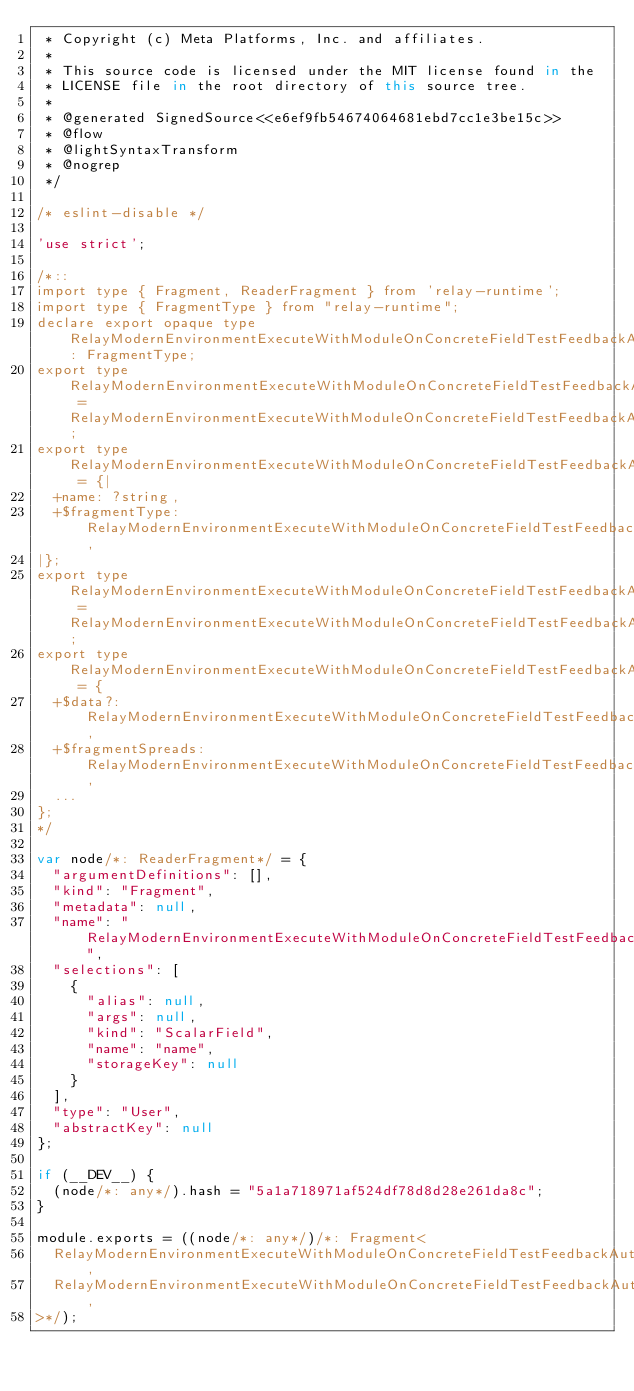Convert code to text. <code><loc_0><loc_0><loc_500><loc_500><_JavaScript_> * Copyright (c) Meta Platforms, Inc. and affiliates.
 * 
 * This source code is licensed under the MIT license found in the
 * LICENSE file in the root directory of this source tree.
 *
 * @generated SignedSource<<e6ef9fb54674064681ebd7cc1e3be15c>>
 * @flow
 * @lightSyntaxTransform
 * @nogrep
 */

/* eslint-disable */

'use strict';

/*::
import type { Fragment, ReaderFragment } from 'relay-runtime';
import type { FragmentType } from "relay-runtime";
declare export opaque type RelayModernEnvironmentExecuteWithModuleOnConcreteFieldTestFeedbackAuthor_author$fragmentType: FragmentType;
export type RelayModernEnvironmentExecuteWithModuleOnConcreteFieldTestFeedbackAuthor_author$ref = RelayModernEnvironmentExecuteWithModuleOnConcreteFieldTestFeedbackAuthor_author$fragmentType;
export type RelayModernEnvironmentExecuteWithModuleOnConcreteFieldTestFeedbackAuthor_author$data = {|
  +name: ?string,
  +$fragmentType: RelayModernEnvironmentExecuteWithModuleOnConcreteFieldTestFeedbackAuthor_author$fragmentType,
|};
export type RelayModernEnvironmentExecuteWithModuleOnConcreteFieldTestFeedbackAuthor_author = RelayModernEnvironmentExecuteWithModuleOnConcreteFieldTestFeedbackAuthor_author$data;
export type RelayModernEnvironmentExecuteWithModuleOnConcreteFieldTestFeedbackAuthor_author$key = {
  +$data?: RelayModernEnvironmentExecuteWithModuleOnConcreteFieldTestFeedbackAuthor_author$data,
  +$fragmentSpreads: RelayModernEnvironmentExecuteWithModuleOnConcreteFieldTestFeedbackAuthor_author$fragmentType,
  ...
};
*/

var node/*: ReaderFragment*/ = {
  "argumentDefinitions": [],
  "kind": "Fragment",
  "metadata": null,
  "name": "RelayModernEnvironmentExecuteWithModuleOnConcreteFieldTestFeedbackAuthor_author",
  "selections": [
    {
      "alias": null,
      "args": null,
      "kind": "ScalarField",
      "name": "name",
      "storageKey": null
    }
  ],
  "type": "User",
  "abstractKey": null
};

if (__DEV__) {
  (node/*: any*/).hash = "5a1a718971af524df78d8d28e261da8c";
}

module.exports = ((node/*: any*/)/*: Fragment<
  RelayModernEnvironmentExecuteWithModuleOnConcreteFieldTestFeedbackAuthor_author$fragmentType,
  RelayModernEnvironmentExecuteWithModuleOnConcreteFieldTestFeedbackAuthor_author$data,
>*/);
</code> 